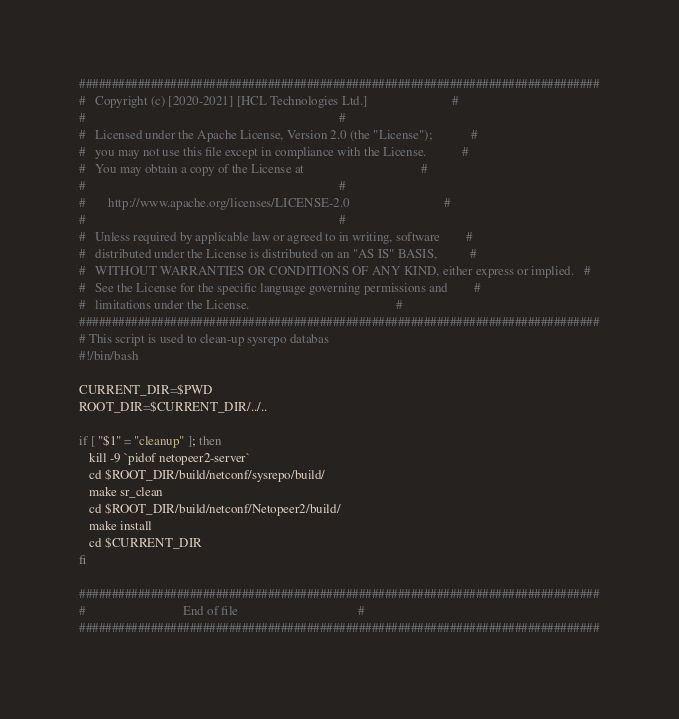<code> <loc_0><loc_0><loc_500><loc_500><_Bash_>################################################################################
#   Copyright (c) [2020-2021] [HCL Technologies Ltd.]                          #
#                                                                              #
#   Licensed under the Apache License, Version 2.0 (the "License");            #
#   you may not use this file except in compliance with the License.           #
#   You may obtain a copy of the License at                                    #
#                                                                              #
#       http://www.apache.org/licenses/LICENSE-2.0                             #
#                                                                              #
#   Unless required by applicable law or agreed to in writing, software        #
#   distributed under the License is distributed on an "AS IS" BASIS,          #
#   WITHOUT WARRANTIES OR CONDITIONS OF ANY KIND, either express or implied.   #
#   See the License for the specific language governing permissions and        #
#   limitations under the License.                                             #
################################################################################
# This script is used to clean-up sysrepo databas
#!/bin/bash

CURRENT_DIR=$PWD
ROOT_DIR=$CURRENT_DIR/../..

if [ "$1" = "cleanup" ]; then
   kill -9 `pidof netopeer2-server`
   cd $ROOT_DIR/build/netconf/sysrepo/build/
   make sr_clean
   cd $ROOT_DIR/build/netconf/Netopeer2/build/
   make install
   cd $CURRENT_DIR
fi

################################################################################
#                              End of file                                     #
################################################################################
</code> 